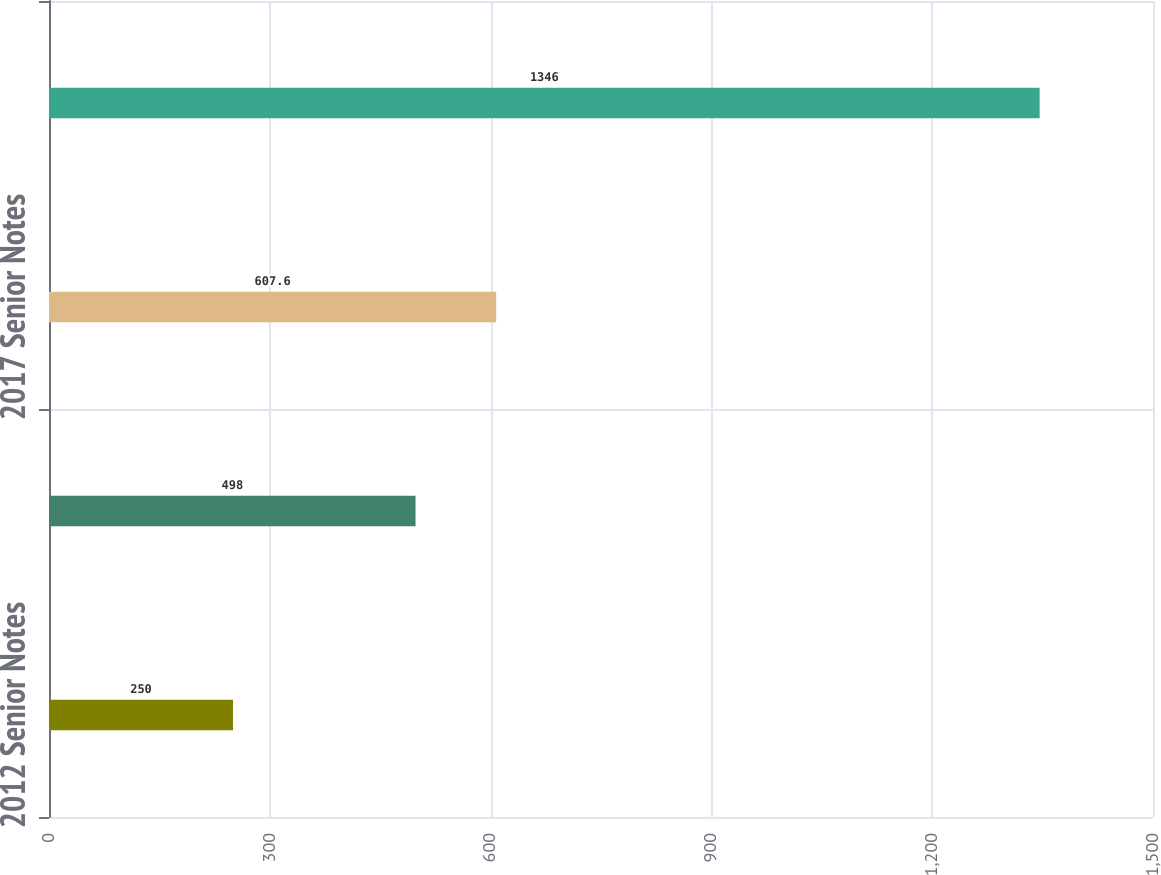Convert chart to OTSL. <chart><loc_0><loc_0><loc_500><loc_500><bar_chart><fcel>2012 Senior Notes<fcel>2015 Senior Notes<fcel>2017 Senior Notes<fcel>Total<nl><fcel>250<fcel>498<fcel>607.6<fcel>1346<nl></chart> 